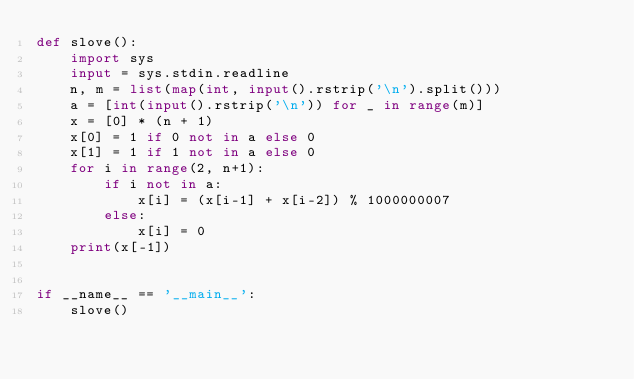<code> <loc_0><loc_0><loc_500><loc_500><_Python_>def slove():
    import sys
    input = sys.stdin.readline
    n, m = list(map(int, input().rstrip('\n').split()))
    a = [int(input().rstrip('\n')) for _ in range(m)]
    x = [0] * (n + 1)
    x[0] = 1 if 0 not in a else 0
    x[1] = 1 if 1 not in a else 0
    for i in range(2, n+1):
        if i not in a:
            x[i] = (x[i-1] + x[i-2]) % 1000000007
        else:
            x[i] = 0
    print(x[-1])


if __name__ == '__main__':
    slove()
</code> 